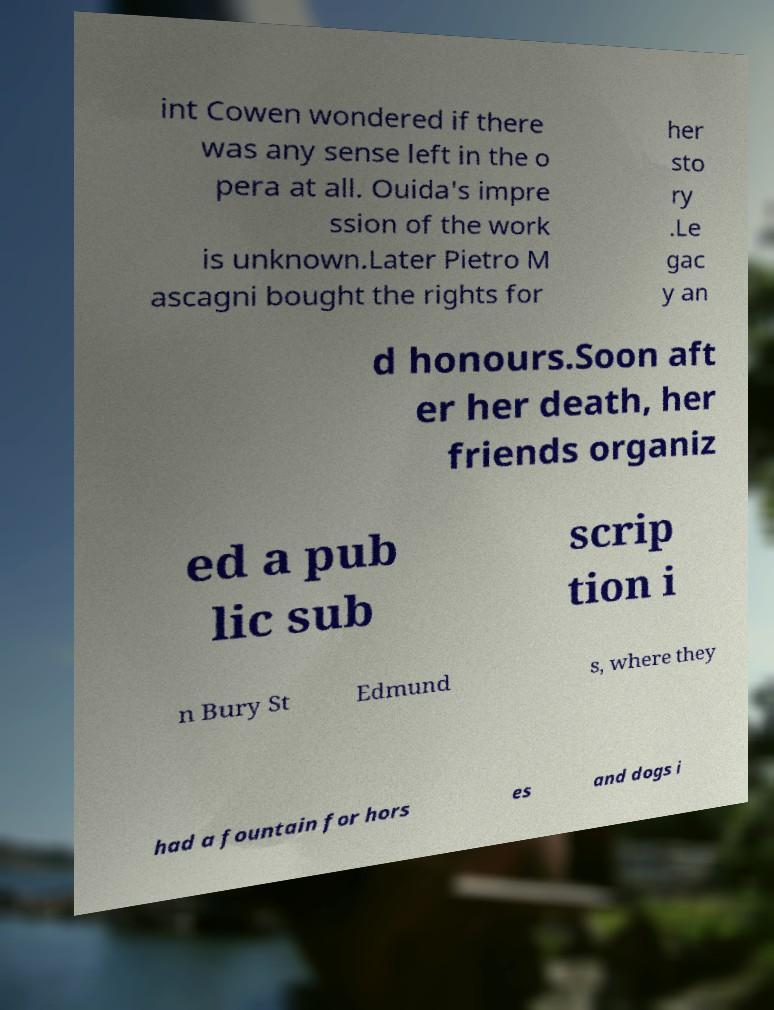Can you accurately transcribe the text from the provided image for me? int Cowen wondered if there was any sense left in the o pera at all. Ouida's impre ssion of the work is unknown.Later Pietro M ascagni bought the rights for her sto ry .Le gac y an d honours.Soon aft er her death, her friends organiz ed a pub lic sub scrip tion i n Bury St Edmund s, where they had a fountain for hors es and dogs i 